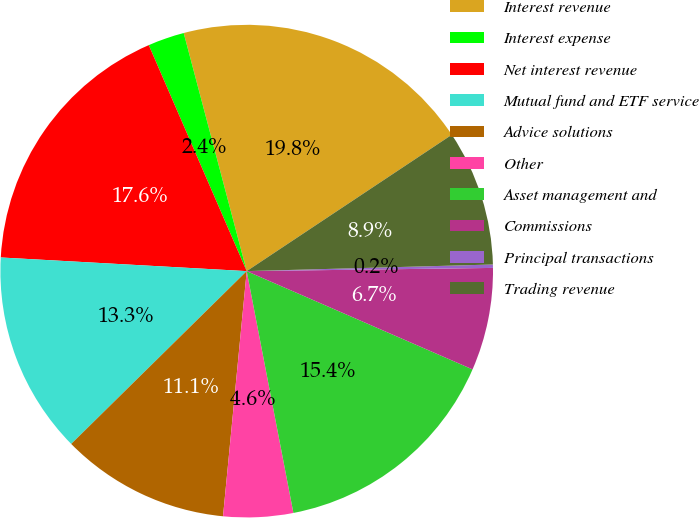Convert chart. <chart><loc_0><loc_0><loc_500><loc_500><pie_chart><fcel>Interest revenue<fcel>Interest expense<fcel>Net interest revenue<fcel>Mutual fund and ETF service<fcel>Advice solutions<fcel>Other<fcel>Asset management and<fcel>Commissions<fcel>Principal transactions<fcel>Trading revenue<nl><fcel>19.78%<fcel>2.39%<fcel>17.61%<fcel>13.26%<fcel>11.09%<fcel>4.57%<fcel>15.43%<fcel>6.74%<fcel>0.22%<fcel>8.91%<nl></chart> 